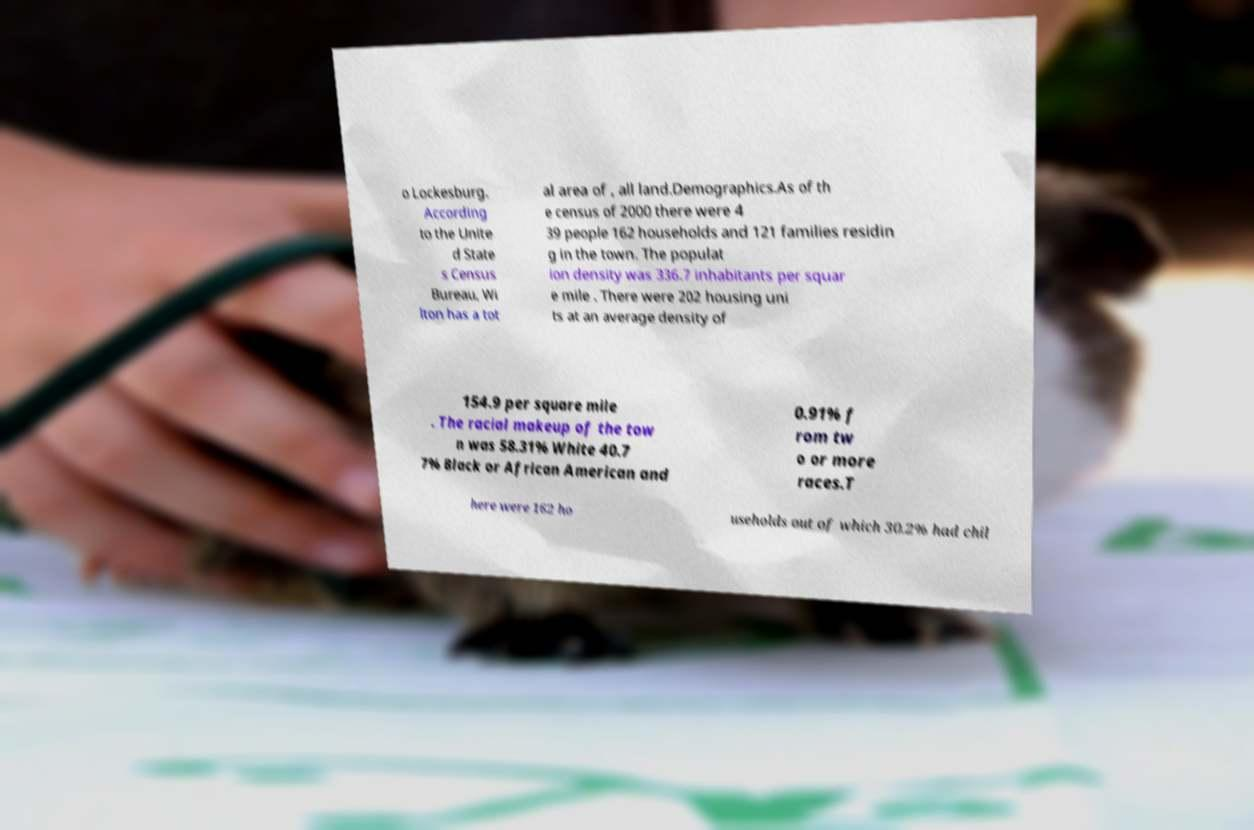Please read and relay the text visible in this image. What does it say? o Lockesburg. According to the Unite d State s Census Bureau, Wi lton has a tot al area of , all land.Demographics.As of th e census of 2000 there were 4 39 people 162 households and 121 families residin g in the town. The populat ion density was 336.7 inhabitants per squar e mile . There were 202 housing uni ts at an average density of 154.9 per square mile . The racial makeup of the tow n was 58.31% White 40.7 7% Black or African American and 0.91% f rom tw o or more races.T here were 162 ho useholds out of which 30.2% had chil 